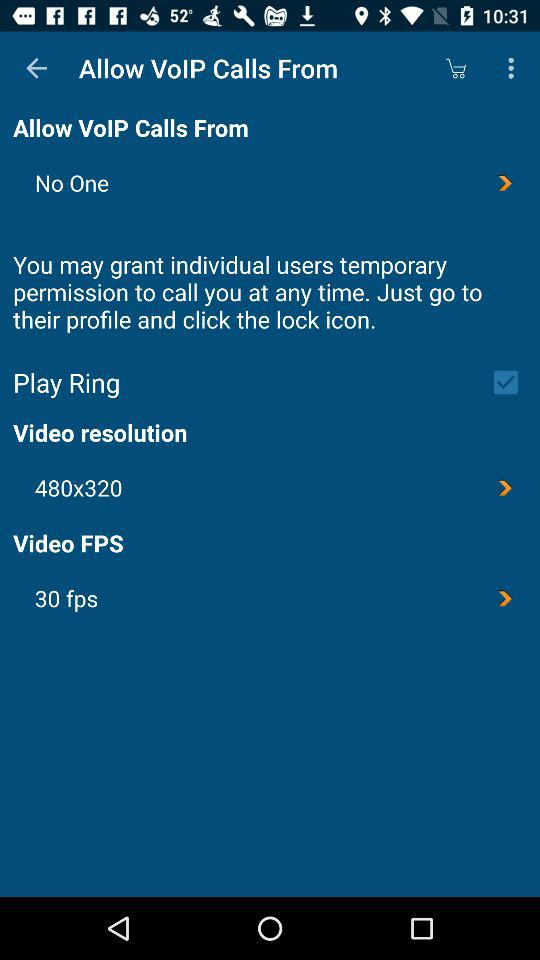What is the status of "Play Ring"? The status of "Play Ring" is "on". 